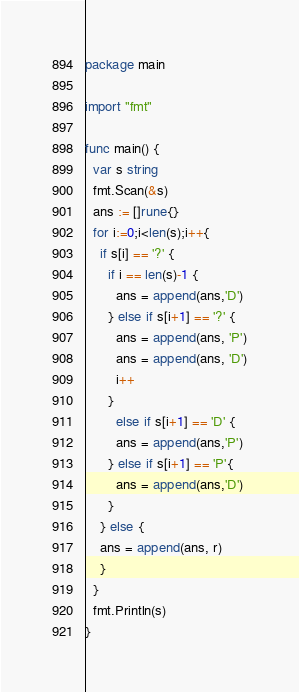<code> <loc_0><loc_0><loc_500><loc_500><_Go_>package main

import "fmt"

func main() {
  var s string
  fmt.Scan(&s)
  ans := []rune{}
  for i:=0;i<len(s);i++{
    if s[i] == '?' {
      if i == len(s)-1 {
        ans = append(ans,'D')
      } else if s[i+1] == '?' {
        ans = append(ans, 'P')
        ans = append(ans, 'D')
        i++
      }
        else if s[i+1] == 'D' {
        ans = append(ans,'P')
      } else if s[i+1] == 'P'{
        ans = append(ans,'D')
      }
    } else {
    ans = append(ans, r)
    }
  }
  fmt.Println(s)
}</code> 